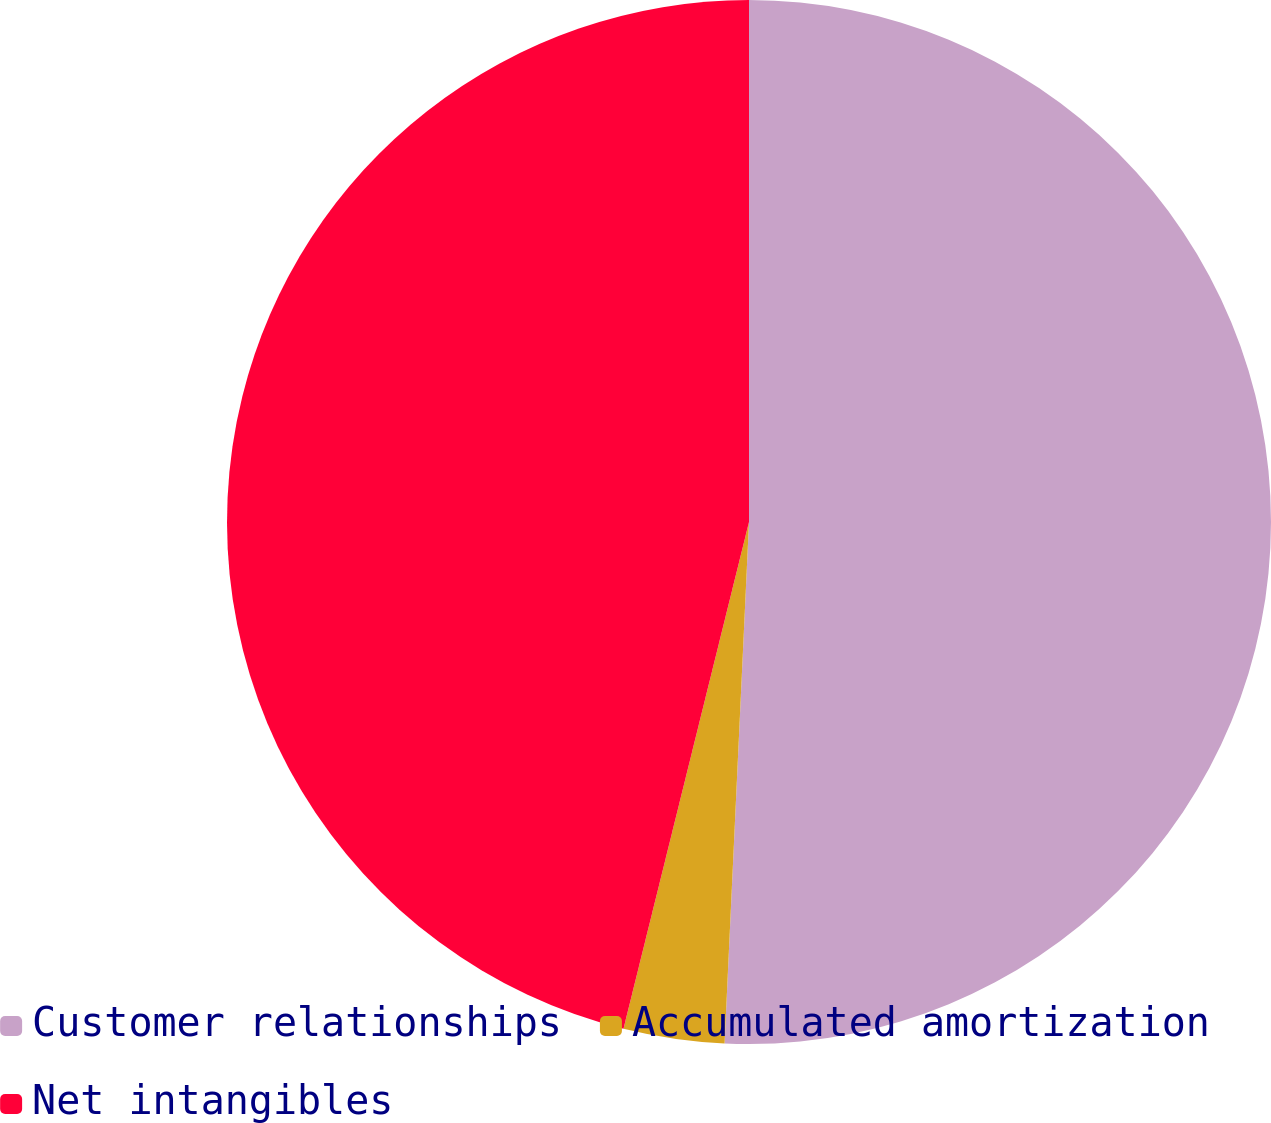Convert chart to OTSL. <chart><loc_0><loc_0><loc_500><loc_500><pie_chart><fcel>Customer relationships<fcel>Accumulated amortization<fcel>Net intangibles<nl><fcel>50.75%<fcel>3.12%<fcel>46.14%<nl></chart> 